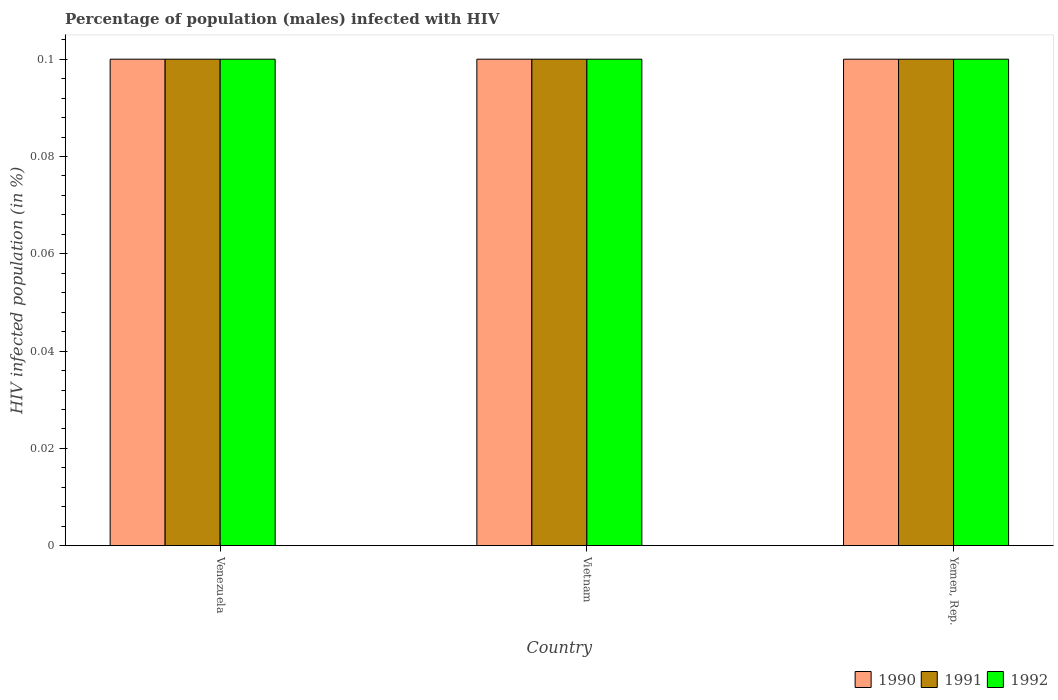How many bars are there on the 2nd tick from the left?
Your answer should be very brief. 3. What is the label of the 1st group of bars from the left?
Provide a short and direct response. Venezuela. In how many cases, is the number of bars for a given country not equal to the number of legend labels?
Keep it short and to the point. 0. What is the percentage of HIV infected male population in 1990 in Venezuela?
Provide a succinct answer. 0.1. Across all countries, what is the maximum percentage of HIV infected male population in 1990?
Your response must be concise. 0.1. Across all countries, what is the minimum percentage of HIV infected male population in 1992?
Provide a succinct answer. 0.1. In which country was the percentage of HIV infected male population in 1992 maximum?
Offer a very short reply. Venezuela. In which country was the percentage of HIV infected male population in 1992 minimum?
Your response must be concise. Venezuela. What is the total percentage of HIV infected male population in 1992 in the graph?
Keep it short and to the point. 0.3. What is the difference between the percentage of HIV infected male population in 1991 in Vietnam and that in Yemen, Rep.?
Offer a very short reply. 0. What is the average percentage of HIV infected male population in 1991 per country?
Provide a succinct answer. 0.1. In how many countries, is the percentage of HIV infected male population in 1992 greater than 0.012 %?
Provide a short and direct response. 3. What is the difference between the highest and the lowest percentage of HIV infected male population in 1991?
Ensure brevity in your answer.  0. In how many countries, is the percentage of HIV infected male population in 1992 greater than the average percentage of HIV infected male population in 1992 taken over all countries?
Ensure brevity in your answer.  0. Is the sum of the percentage of HIV infected male population in 1992 in Vietnam and Yemen, Rep. greater than the maximum percentage of HIV infected male population in 1990 across all countries?
Provide a succinct answer. Yes. How many bars are there?
Your answer should be very brief. 9. Are all the bars in the graph horizontal?
Provide a succinct answer. No. How many countries are there in the graph?
Provide a succinct answer. 3. Does the graph contain grids?
Your answer should be very brief. No. Where does the legend appear in the graph?
Your response must be concise. Bottom right. What is the title of the graph?
Keep it short and to the point. Percentage of population (males) infected with HIV. What is the label or title of the X-axis?
Make the answer very short. Country. What is the label or title of the Y-axis?
Offer a very short reply. HIV infected population (in %). What is the HIV infected population (in %) in 1990 in Venezuela?
Make the answer very short. 0.1. What is the HIV infected population (in %) in 1991 in Venezuela?
Provide a succinct answer. 0.1. What is the HIV infected population (in %) in 1992 in Venezuela?
Make the answer very short. 0.1. What is the HIV infected population (in %) of 1990 in Vietnam?
Give a very brief answer. 0.1. What is the HIV infected population (in %) of 1991 in Vietnam?
Provide a succinct answer. 0.1. What is the HIV infected population (in %) of 1992 in Vietnam?
Offer a terse response. 0.1. Across all countries, what is the maximum HIV infected population (in %) in 1990?
Offer a very short reply. 0.1. Across all countries, what is the maximum HIV infected population (in %) in 1991?
Your response must be concise. 0.1. Across all countries, what is the minimum HIV infected population (in %) in 1990?
Your response must be concise. 0.1. What is the total HIV infected population (in %) in 1990 in the graph?
Provide a succinct answer. 0.3. What is the total HIV infected population (in %) of 1992 in the graph?
Offer a very short reply. 0.3. What is the difference between the HIV infected population (in %) in 1990 in Venezuela and that in Vietnam?
Offer a terse response. 0. What is the difference between the HIV infected population (in %) in 1992 in Venezuela and that in Yemen, Rep.?
Make the answer very short. 0. What is the difference between the HIV infected population (in %) in 1990 in Vietnam and that in Yemen, Rep.?
Your answer should be very brief. 0. What is the difference between the HIV infected population (in %) in 1990 in Venezuela and the HIV infected population (in %) in 1992 in Vietnam?
Your response must be concise. 0. What is the difference between the HIV infected population (in %) in 1991 in Venezuela and the HIV infected population (in %) in 1992 in Vietnam?
Keep it short and to the point. 0. What is the difference between the HIV infected population (in %) of 1990 in Venezuela and the HIV infected population (in %) of 1992 in Yemen, Rep.?
Provide a succinct answer. 0. What is the difference between the HIV infected population (in %) in 1990 in Vietnam and the HIV infected population (in %) in 1991 in Yemen, Rep.?
Offer a terse response. 0. What is the difference between the HIV infected population (in %) in 1990 in Vietnam and the HIV infected population (in %) in 1992 in Yemen, Rep.?
Make the answer very short. 0. What is the difference between the HIV infected population (in %) in 1990 and HIV infected population (in %) in 1992 in Vietnam?
Your response must be concise. 0. What is the difference between the HIV infected population (in %) in 1990 and HIV infected population (in %) in 1991 in Yemen, Rep.?
Give a very brief answer. 0. What is the difference between the HIV infected population (in %) in 1991 and HIV infected population (in %) in 1992 in Yemen, Rep.?
Provide a succinct answer. 0. What is the ratio of the HIV infected population (in %) in 1991 in Venezuela to that in Vietnam?
Give a very brief answer. 1. What is the ratio of the HIV infected population (in %) of 1990 in Venezuela to that in Yemen, Rep.?
Keep it short and to the point. 1. What is the ratio of the HIV infected population (in %) in 1992 in Vietnam to that in Yemen, Rep.?
Ensure brevity in your answer.  1. What is the difference between the highest and the second highest HIV infected population (in %) in 1990?
Your answer should be compact. 0. What is the difference between the highest and the second highest HIV infected population (in %) in 1991?
Your answer should be very brief. 0. What is the difference between the highest and the second highest HIV infected population (in %) in 1992?
Your response must be concise. 0. What is the difference between the highest and the lowest HIV infected population (in %) of 1991?
Your answer should be very brief. 0. 